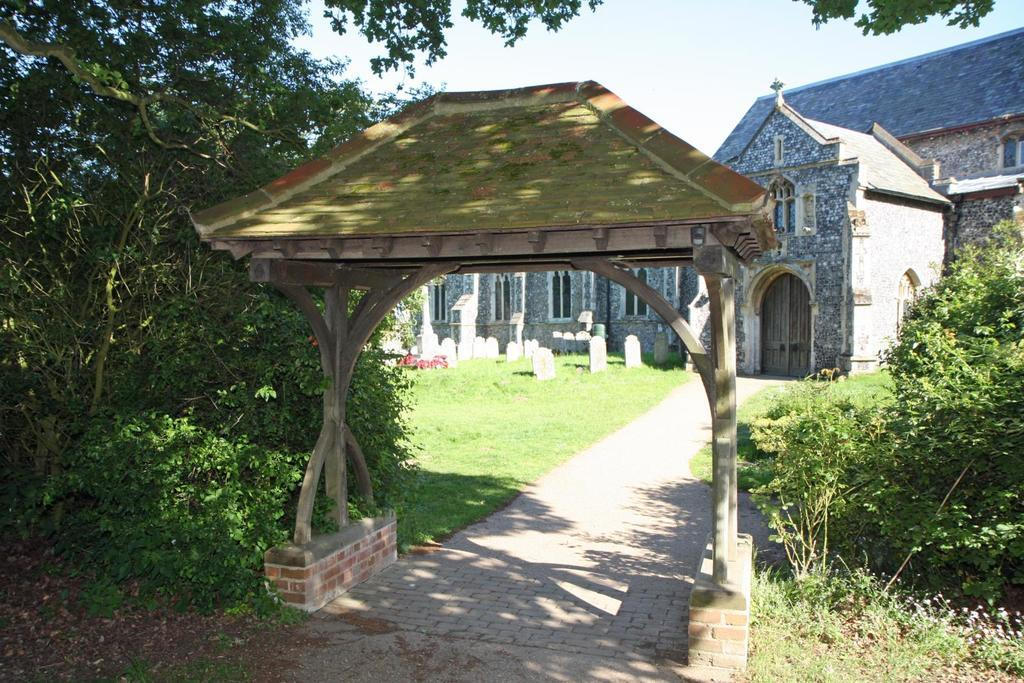What is located in the foreground of the image? There is an entrance poll and a path in the foreground of the image. What type of vegetation is present in the foreground of the image? There is greenery in the foreground of the image. What can be seen in the background of the image? There is a building, grassland, headstones, and the sky visible in the background of the image. What type of bottle can be seen in the image? There is no bottle present in the image. 